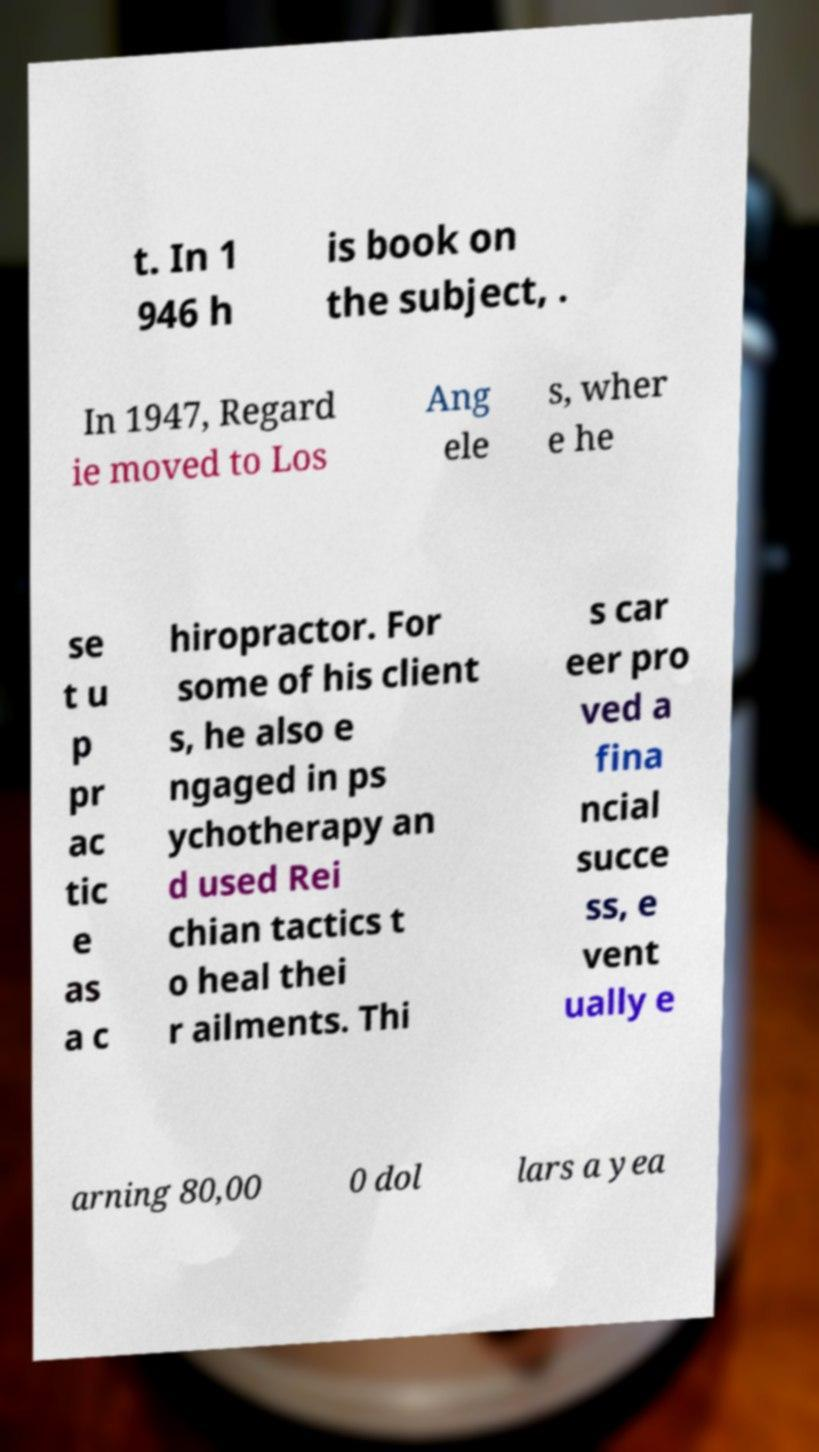Please identify and transcribe the text found in this image. t. In 1 946 h is book on the subject, . In 1947, Regard ie moved to Los Ang ele s, wher e he se t u p pr ac tic e as a c hiropractor. For some of his client s, he also e ngaged in ps ychotherapy an d used Rei chian tactics t o heal thei r ailments. Thi s car eer pro ved a fina ncial succe ss, e vent ually e arning 80,00 0 dol lars a yea 